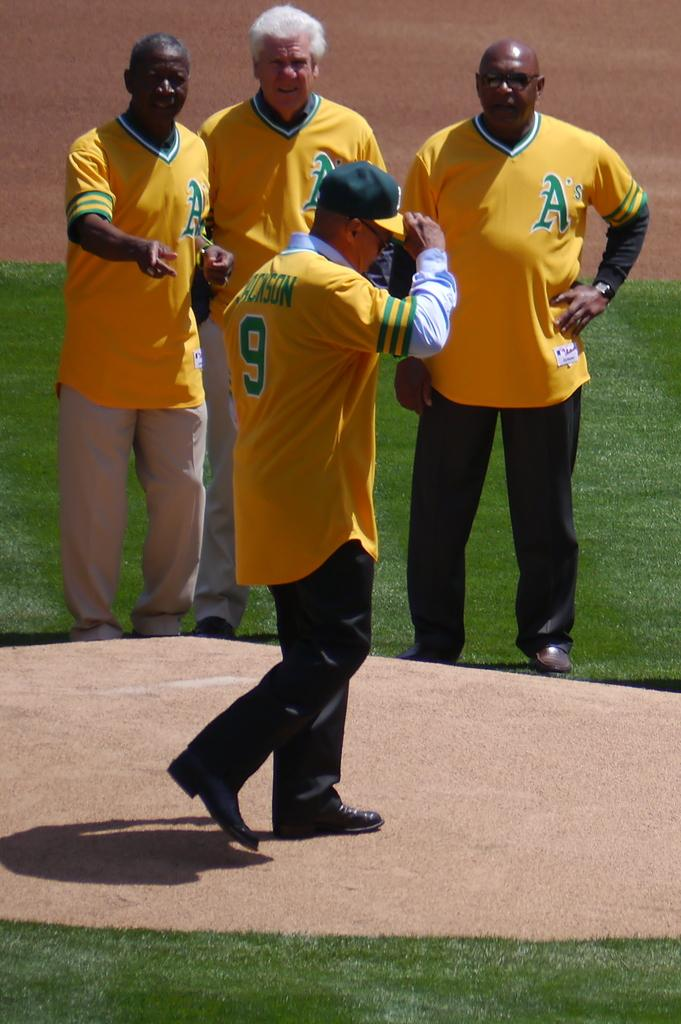Provide a one-sentence caption for the provided image. The men are wearing Oakland A's yellow and green jersey. 